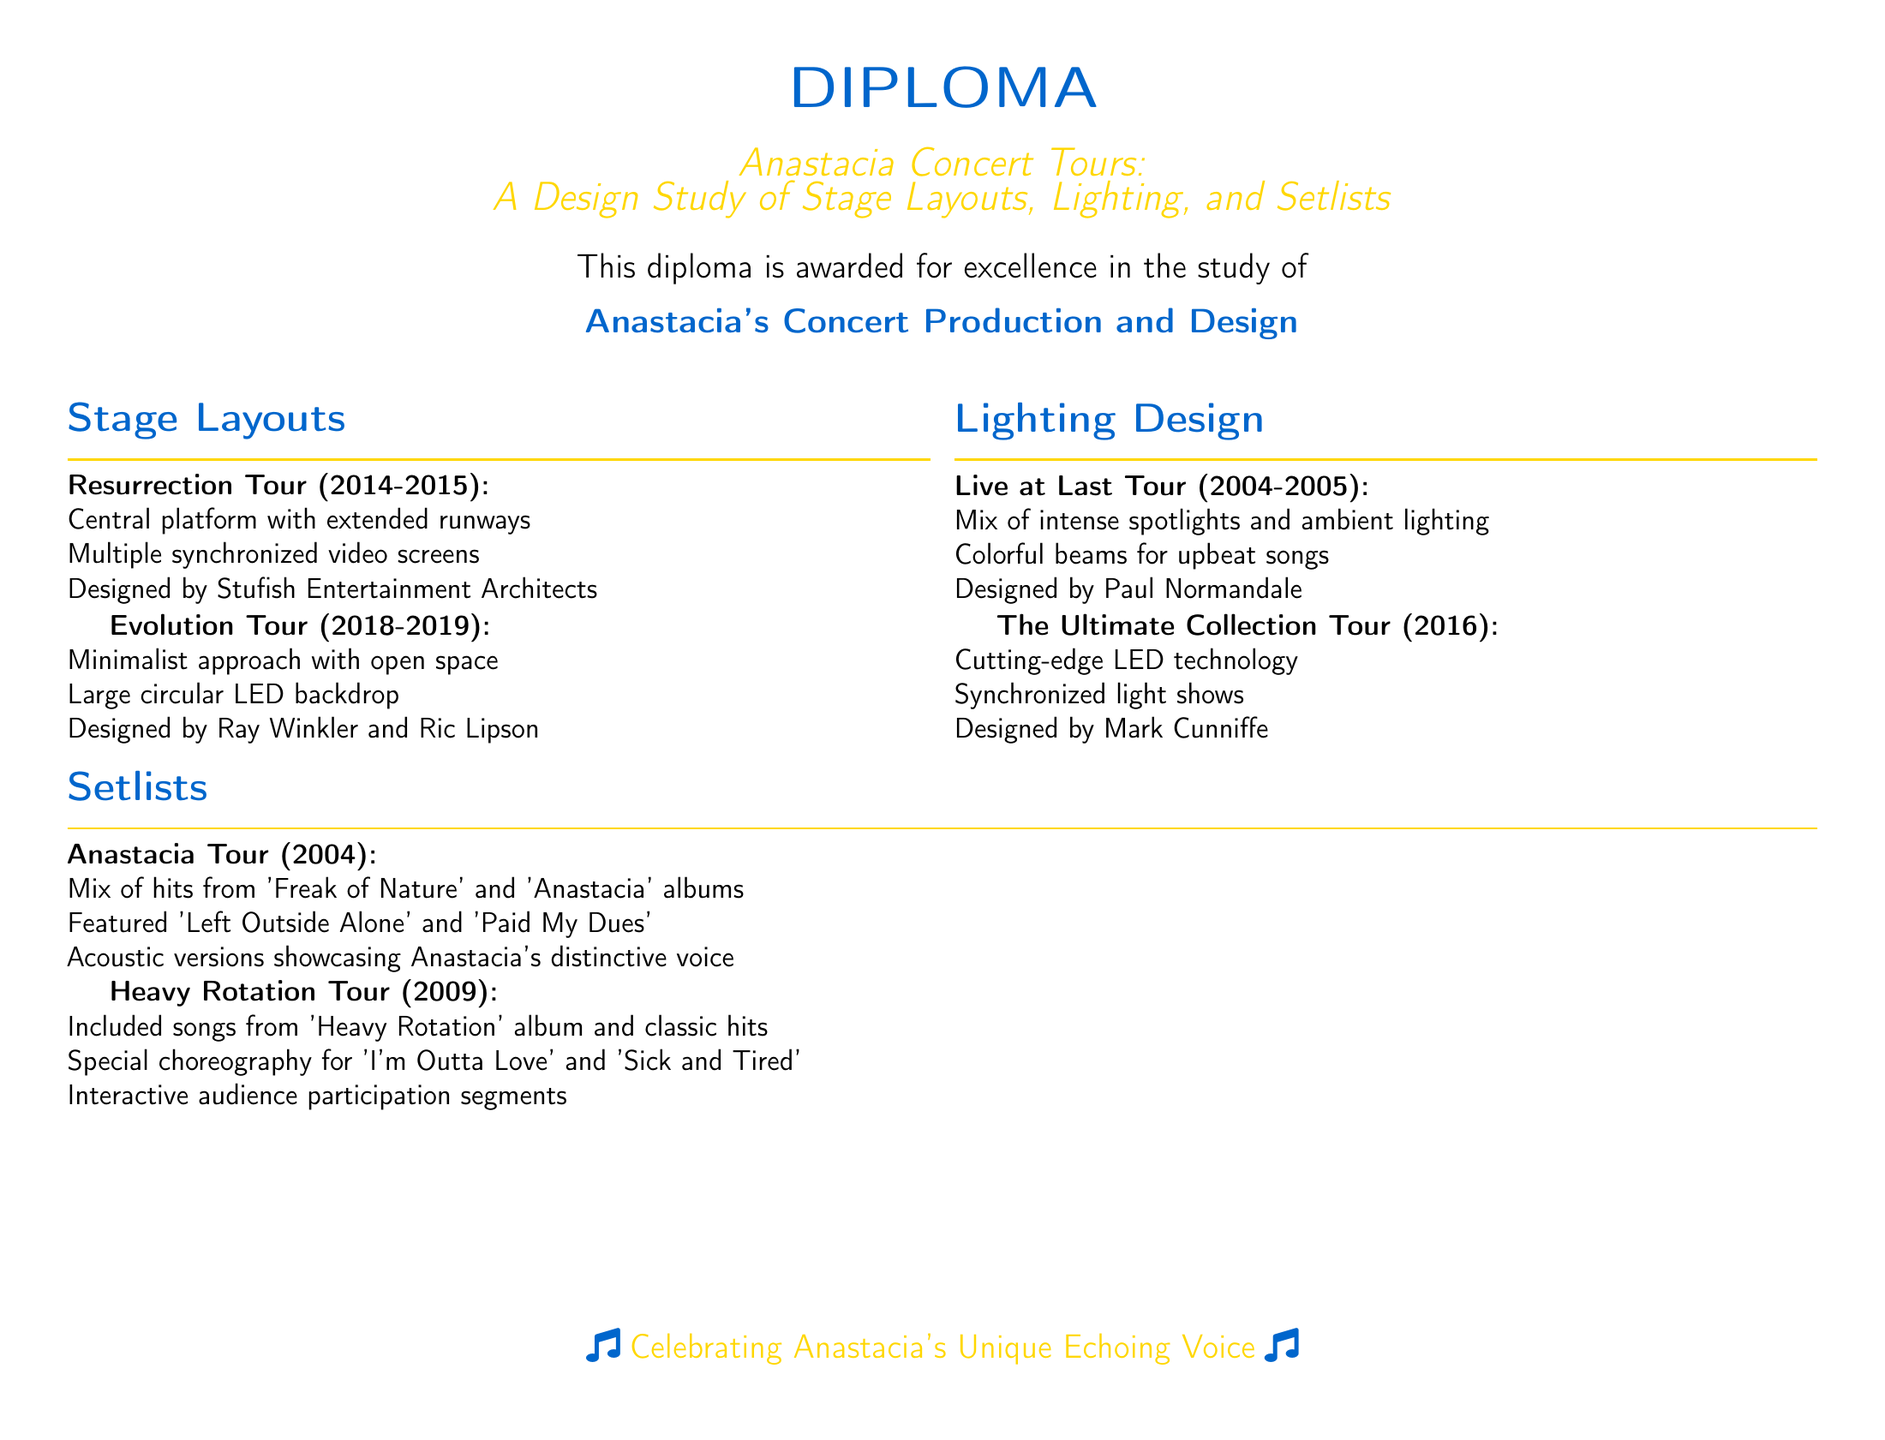What is the name of the study? The study's title is provided at the top of the document, showcasing the focus on Anastacia's concert tours.
Answer: Anastacia Concert Tours: A Design Study of Stage Layouts, Lighting, and Setlists Who designed the Resurrection Tour stage? The document lists the designer of the stage layout for the Resurrection Tour.
Answer: Stufish Entertainment Architects What year did the Live at Last Tour take place? The document specifies the years associated with the Live at Last Tour.
Answer: 2004-2005 What type of lighting design was used in The Ultimate Collection Tour? The lighting design for The Ultimate Collection Tour is described in the document.
Answer: Cutting-edge LED technology Which song featured special choreography in the Heavy Rotation Tour? The document mentions a specific song that included choreography during the Heavy Rotation Tour.
Answer: I'm Outta Love What design approach was taken for the Evolution Tour? The document summarizes the design approach for the stage layout in the Evolution Tour.
Answer: Minimalist approach with open space Which albums were featured in the setlist for the Anastacia Tour? The setlist for the Anastacia Tour includes songs from two specific albums.
Answer: Freak of Nature and Anastacia Who designed the lighting for the Live at Last Tour? The designer of the lighting for this tour is mentioned within the lighting design section.
Answer: Paul Normandale 